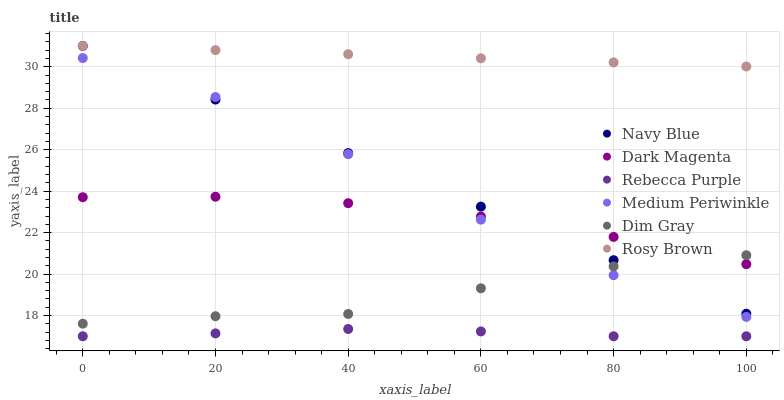Does Rebecca Purple have the minimum area under the curve?
Answer yes or no. Yes. Does Rosy Brown have the maximum area under the curve?
Answer yes or no. Yes. Does Dark Magenta have the minimum area under the curve?
Answer yes or no. No. Does Dark Magenta have the maximum area under the curve?
Answer yes or no. No. Is Navy Blue the smoothest?
Answer yes or no. Yes. Is Medium Periwinkle the roughest?
Answer yes or no. Yes. Is Dark Magenta the smoothest?
Answer yes or no. No. Is Dark Magenta the roughest?
Answer yes or no. No. Does Rebecca Purple have the lowest value?
Answer yes or no. Yes. Does Dark Magenta have the lowest value?
Answer yes or no. No. Does Rosy Brown have the highest value?
Answer yes or no. Yes. Does Dark Magenta have the highest value?
Answer yes or no. No. Is Rebecca Purple less than Rosy Brown?
Answer yes or no. Yes. Is Rosy Brown greater than Medium Periwinkle?
Answer yes or no. Yes. Does Dim Gray intersect Medium Periwinkle?
Answer yes or no. Yes. Is Dim Gray less than Medium Periwinkle?
Answer yes or no. No. Is Dim Gray greater than Medium Periwinkle?
Answer yes or no. No. Does Rebecca Purple intersect Rosy Brown?
Answer yes or no. No. 